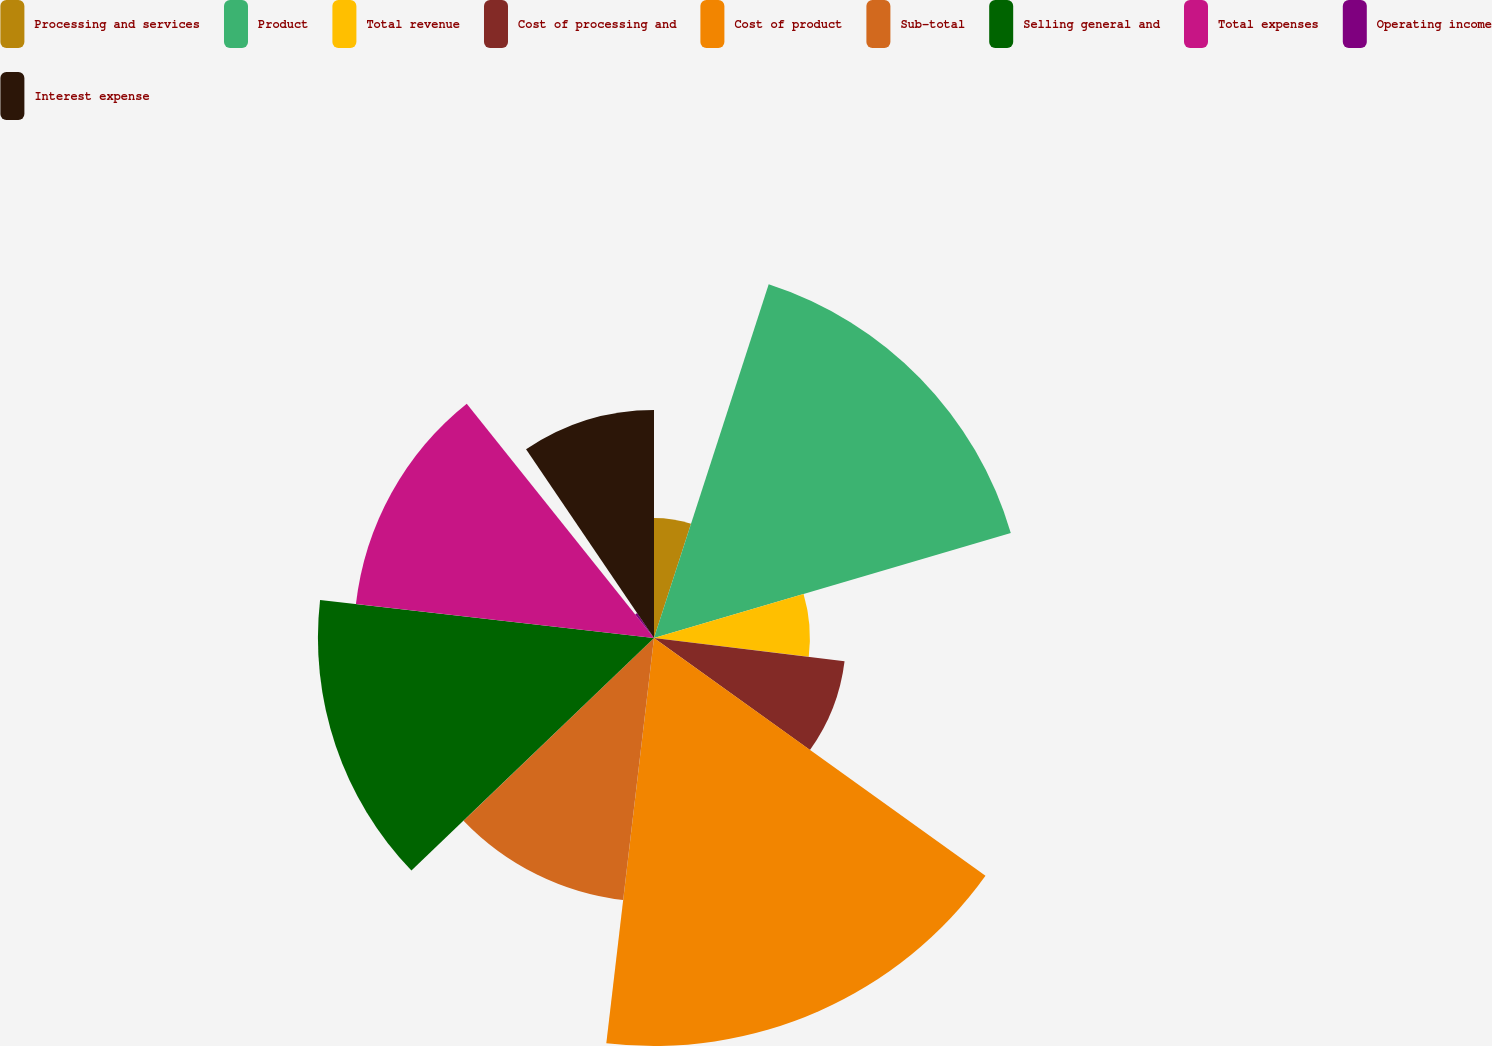<chart> <loc_0><loc_0><loc_500><loc_500><pie_chart><fcel>Processing and services<fcel>Product<fcel>Total revenue<fcel>Cost of processing and<fcel>Cost of product<fcel>Sub-total<fcel>Selling general and<fcel>Total expenses<fcel>Operating income<fcel>Interest expense<nl><fcel>4.99%<fcel>15.46%<fcel>6.48%<fcel>7.98%<fcel>16.96%<fcel>10.97%<fcel>13.97%<fcel>12.47%<fcel>1.25%<fcel>9.48%<nl></chart> 